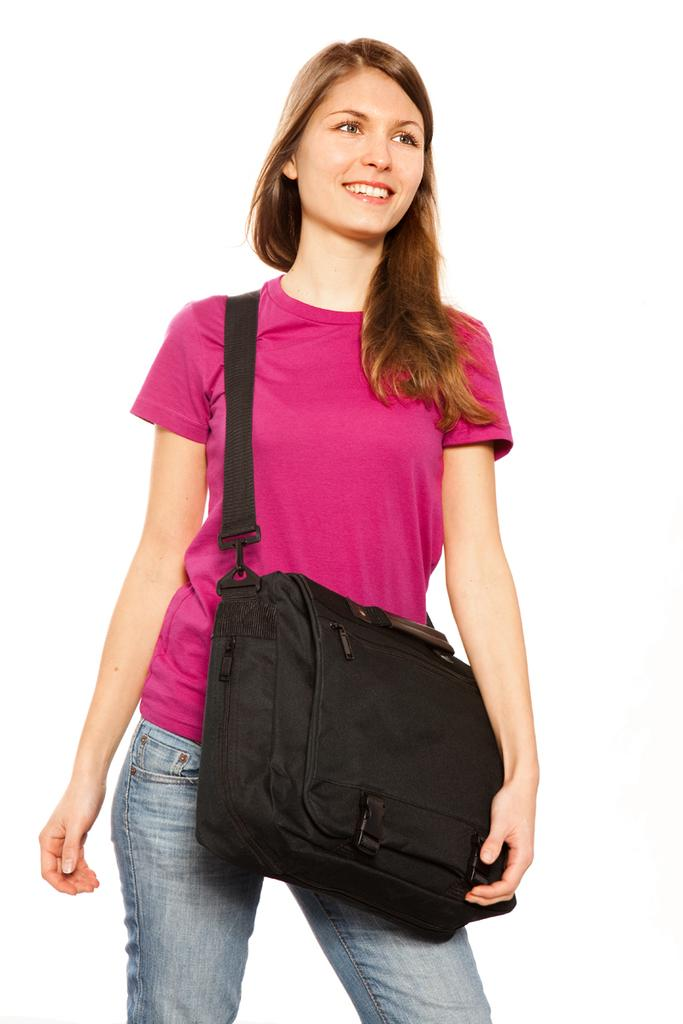Who is the main subject in the image? There is a woman in the image. What is the woman doing in the image? The woman is standing in the image. What is the woman holding in the image? The woman is holding a bag in the image. What color is the woman's t-shirt in the image? The woman is wearing a pink t-shirt in the image. What type of pants is the woman wearing in the image? The woman is wearing blue jeans in the image. Can you see any magic happening around the woman in the image? There is no magic present in the image; it only shows a woman standing and holding a bag. 